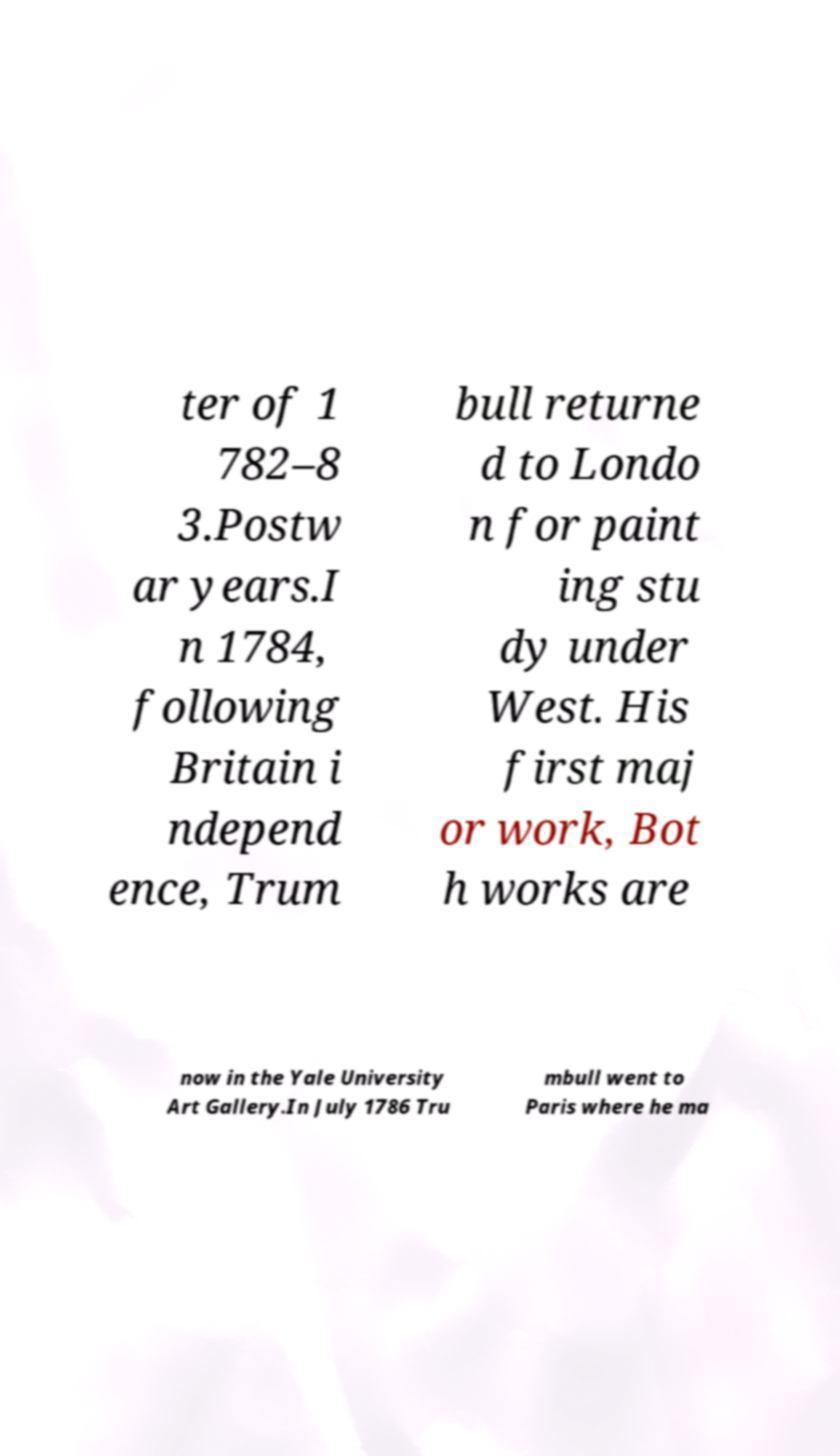Can you accurately transcribe the text from the provided image for me? ter of 1 782–8 3.Postw ar years.I n 1784, following Britain i ndepend ence, Trum bull returne d to Londo n for paint ing stu dy under West. His first maj or work, Bot h works are now in the Yale University Art Gallery.In July 1786 Tru mbull went to Paris where he ma 